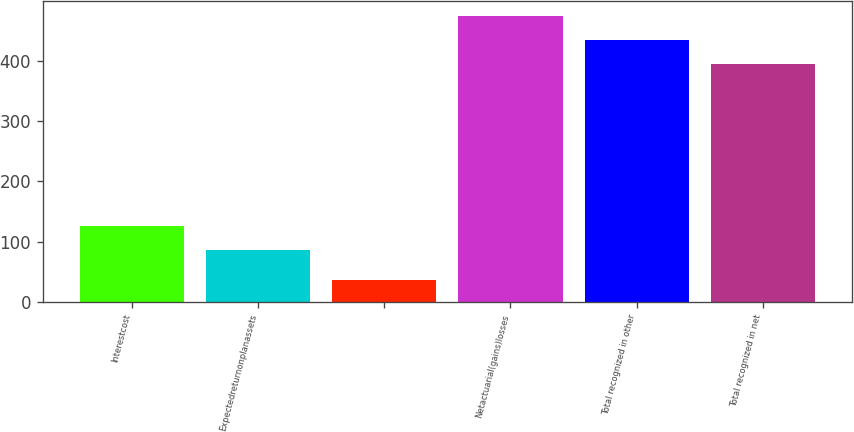<chart> <loc_0><loc_0><loc_500><loc_500><bar_chart><fcel>Interestcost<fcel>Expectedreturnonplanassets<fcel>Unnamed: 2<fcel>Netactuarial(gains)losses<fcel>Total recognized in other<fcel>Total recognized in net<nl><fcel>126.4<fcel>86<fcel>36<fcel>475.8<fcel>435.4<fcel>395<nl></chart> 